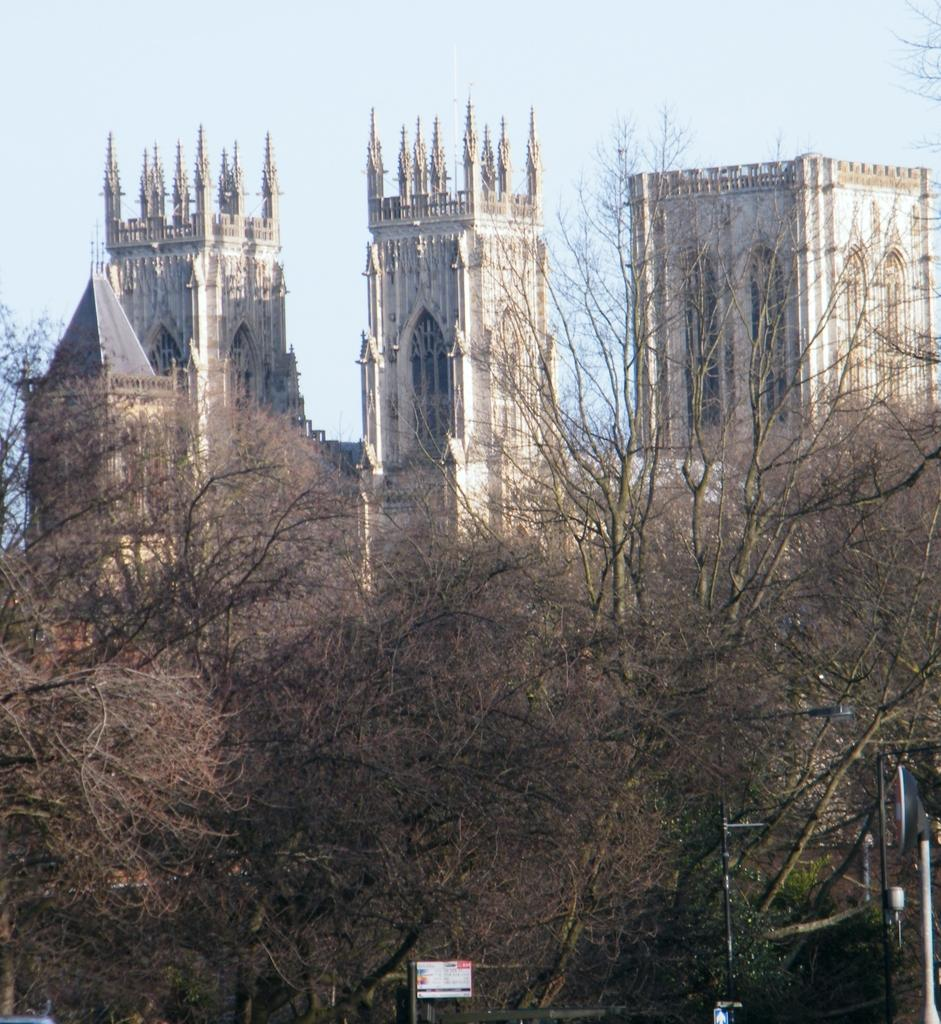What type of structure is in the image? There is a castle in the image. What type of vegetation is present in the image? There are trees in the image. What other objects can be seen in the image? There are poles in the image. What is visible in the background of the image? The sky is visible in the image. How many frogs are sitting on the cake in the image? There is no cake or frogs present in the image. Can you describe the flight of the birds in the image? There are no birds or flight depicted in the image. 